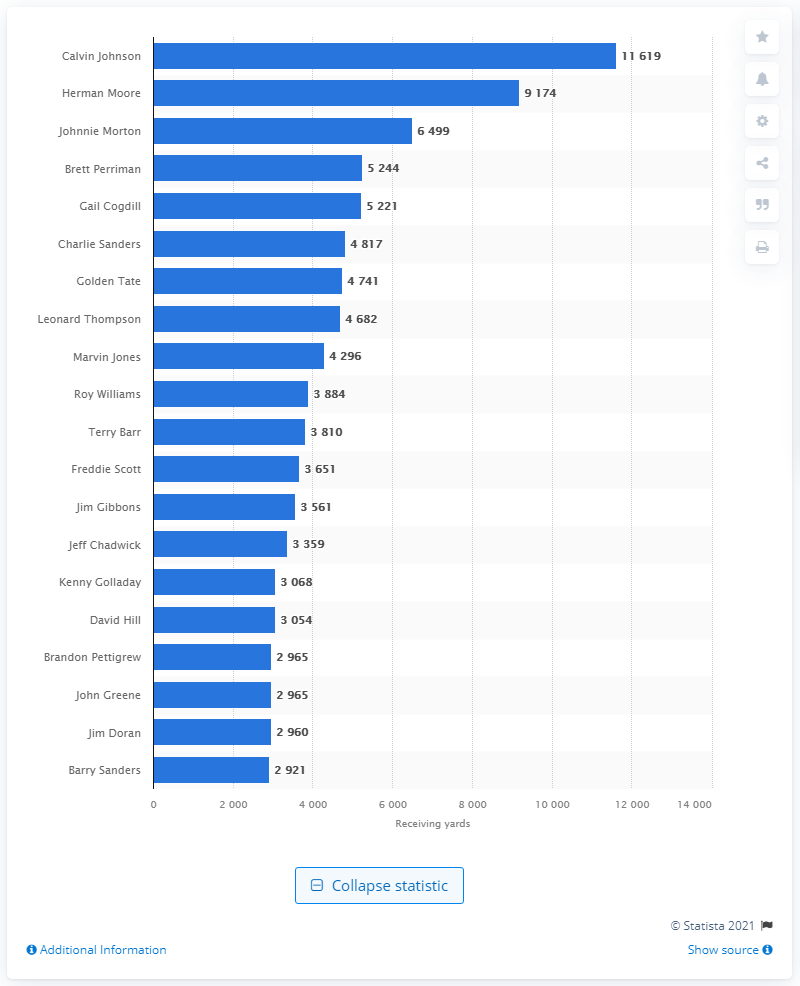Draw attention to some important aspects in this diagram. Calvin Johnson is the all-time career receiving leader for the Detroit Lions. 